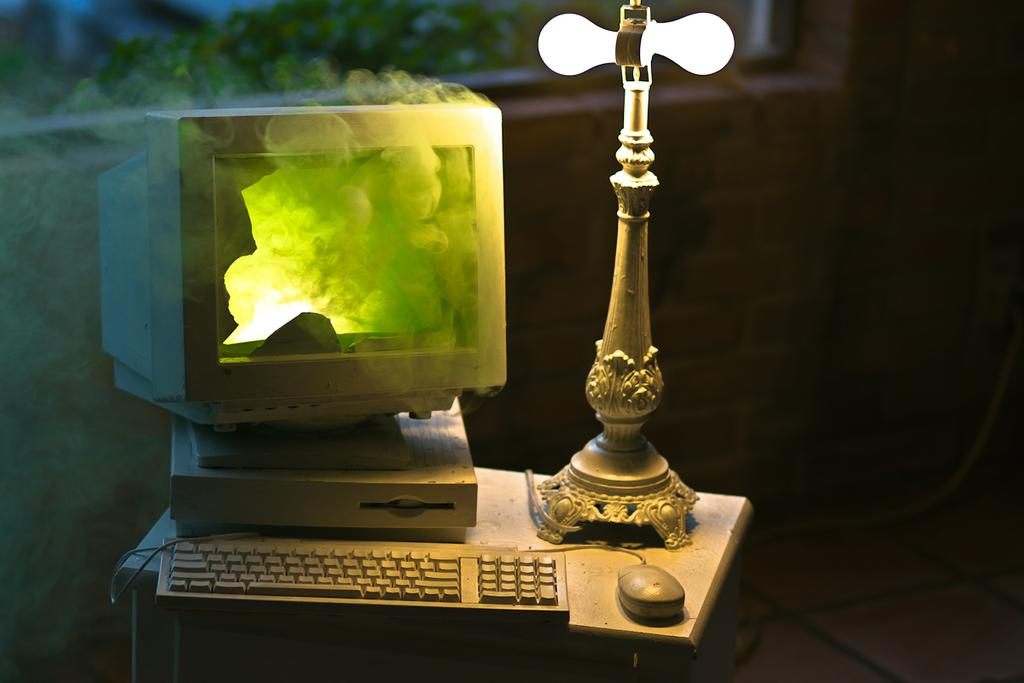What piece of furniture is present in the image? There is a table in the image. What object is on the table that provides light? There is a table lamp on the table. What electronic device is on the table for typing? There is a keyboard on the table. What pointing device is on the table for use with the keyboard? There is a mouse on the table. What electronic device is on the table but not functioning properly? There is a broken monitor on the table. What can be seen in the image that is not related to the table or its contents? There is smoke visible in the image. What type of plant is growing on the keyboard in the image? There is no plant growing on the keyboard in the image; it is a keyboard for typing. 